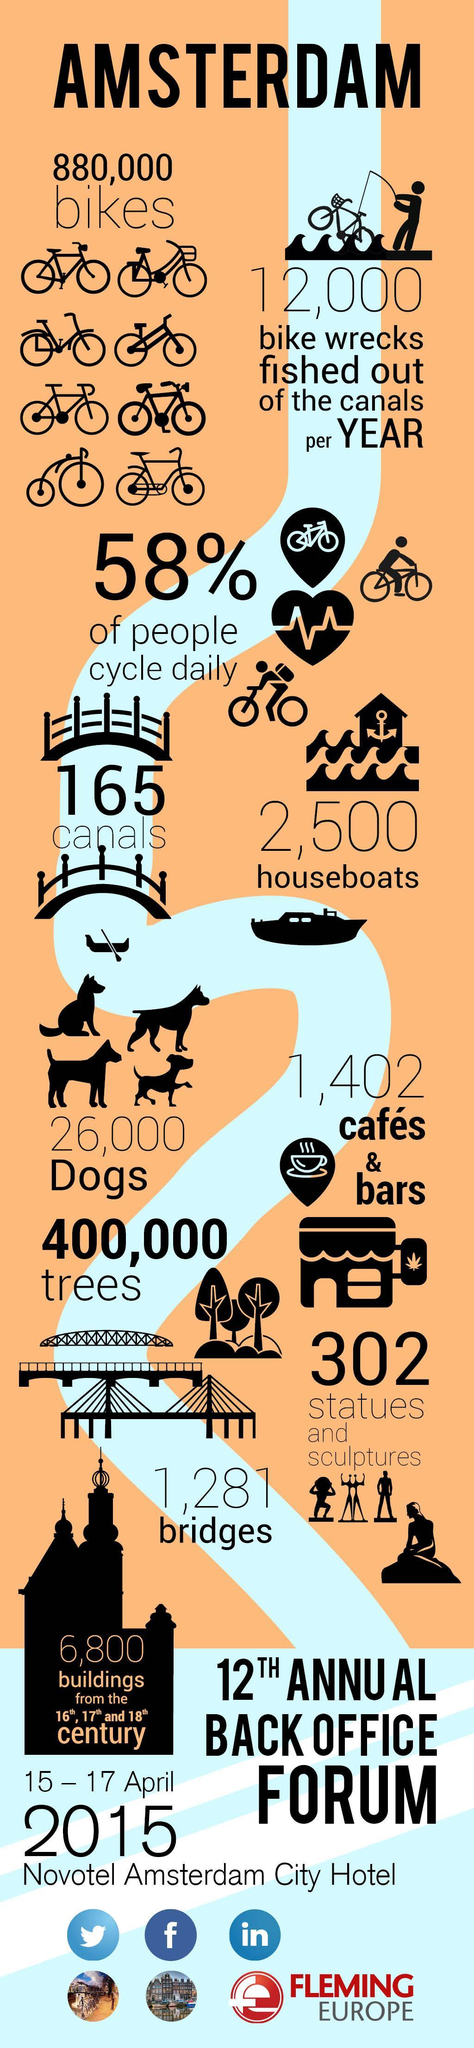What percentage of people  do not cycle in Amsterdam?
Answer the question with a short phrase. 42% 